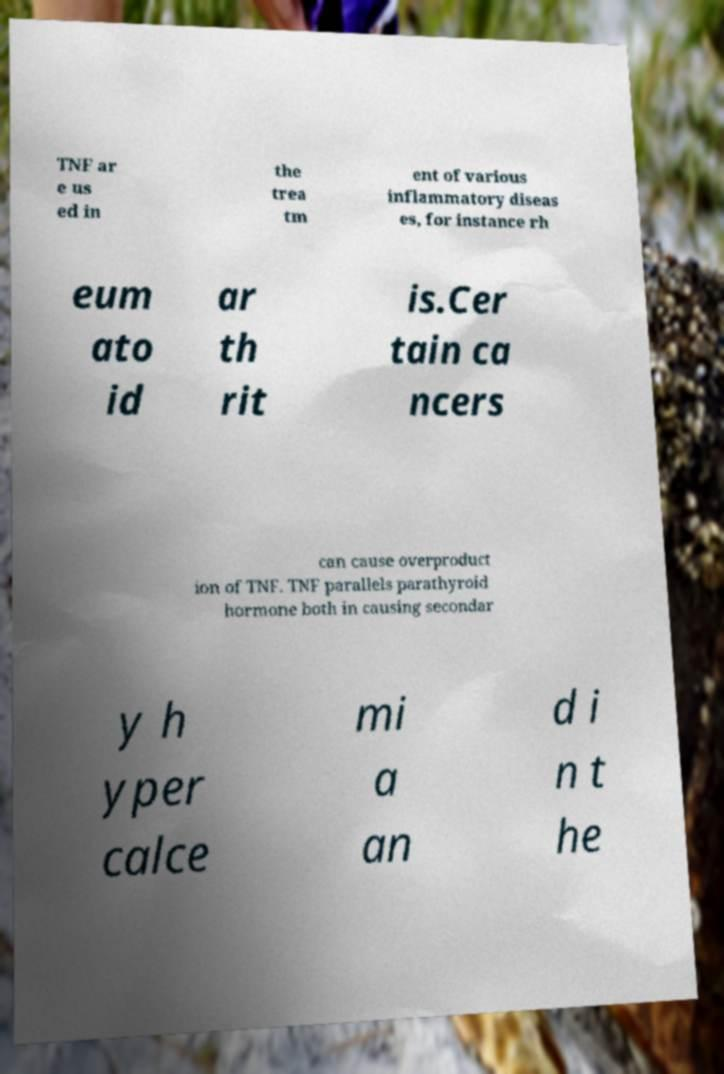Can you accurately transcribe the text from the provided image for me? TNF ar e us ed in the trea tm ent of various inflammatory diseas es, for instance rh eum ato id ar th rit is.Cer tain ca ncers can cause overproduct ion of TNF. TNF parallels parathyroid hormone both in causing secondar y h yper calce mi a an d i n t he 